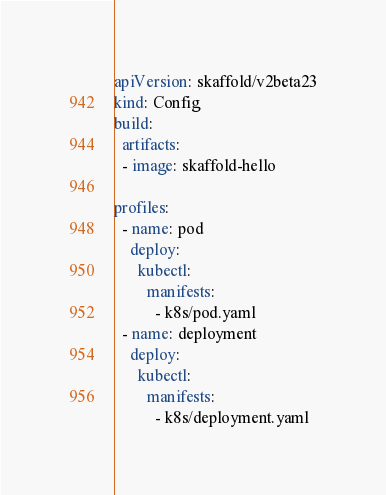Convert code to text. <code><loc_0><loc_0><loc_500><loc_500><_YAML_>apiVersion: skaffold/v2beta23
kind: Config
build:
  artifacts:
  - image: skaffold-hello

profiles:
  - name: pod
    deploy:
      kubectl:
        manifests:
          - k8s/pod.yaml
  - name: deployment
    deploy:
      kubectl:
        manifests:
          - k8s/deployment.yaml</code> 